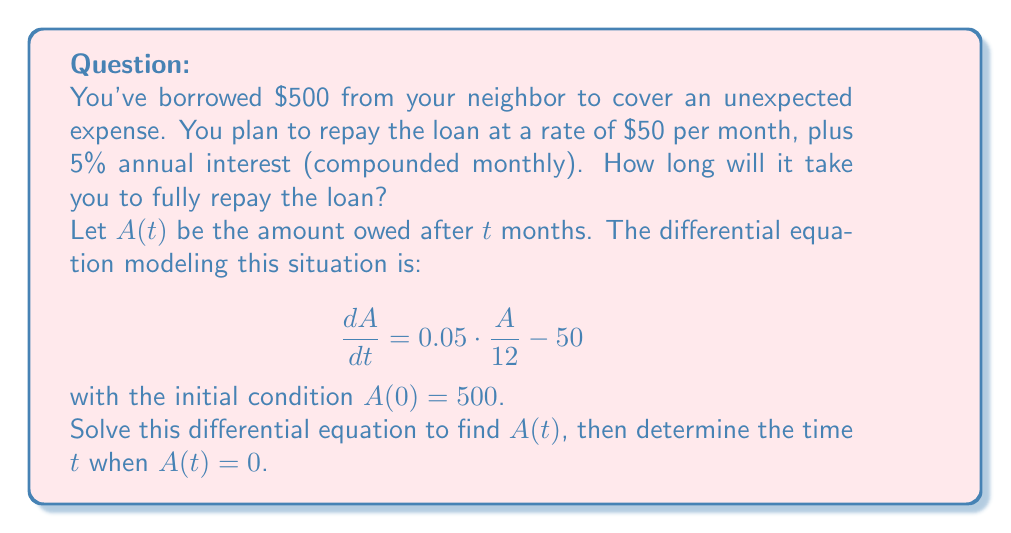What is the answer to this math problem? Let's solve this step-by-step:

1) The differential equation is:
   $$\frac{dA}{dt} = \frac{0.05}{12}A - 50$$

2) This is a linear first-order differential equation of the form:
   $$\frac{dA}{dt} + P(t)A = Q(t)$$
   where $P(t) = -\frac{0.05}{12}$ and $Q(t) = -50$

3) The integrating factor is:
   $$\mu(t) = e^{\int P(t) dt} = e^{-\frac{0.05}{12}t}$$

4) Multiplying both sides by $\mu(t)$:
   $$e^{-\frac{0.05}{12}t}\frac{dA}{dt} + \frac{0.05}{12}e^{-\frac{0.05}{12}t}A = -50e^{-\frac{0.05}{12}t}$$

5) This can be written as:
   $$\frac{d}{dt}(Ae^{-\frac{0.05}{12}t}) = -50e^{-\frac{0.05}{12}t}$$

6) Integrating both sides:
   $$Ae^{-\frac{0.05}{12}t} = 12000 + C$$

7) Solving for $A$:
   $$A(t) = 12000e^{\frac{0.05}{12}t} + Ce^{\frac{0.05}{12}t}$$

8) Using the initial condition $A(0) = 500$:
   $$500 = 12000 + C$$
   $$C = -11500$$

9) Therefore, the solution is:
   $$A(t) = 12000e^{\frac{0.05}{12}t} - 11500e^{\frac{0.05}{12}t}$$
   $$A(t) = 500e^{\frac{0.05}{12}t}$$

10) To find when the loan is fully repaid, we set $A(t) = 0$:
    $$500e^{\frac{0.05}{12}t} = 0$$

    This is never exactly zero, but we can find when it's very close to zero.

11) Let's say it's repaid when the amount is less than 1 cent:
    $$500e^{\frac{0.05}{12}t} < 0.01$$

12) Solving for $t$:
    $$e^{\frac{0.05}{12}t} < \frac{0.01}{500}$$
    $$\frac{0.05}{12}t < \ln(\frac{0.01}{500})$$
    $$t > \frac{12}{0.05} \ln(50000) \approx 10.82$$

Therefore, it will take about 11 months to repay the loan.
Answer: 11 months 